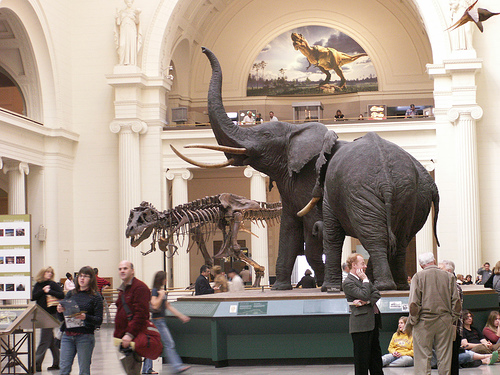<image>
Can you confirm if the elephant is above the stand? No. The elephant is not positioned above the stand. The vertical arrangement shows a different relationship. 